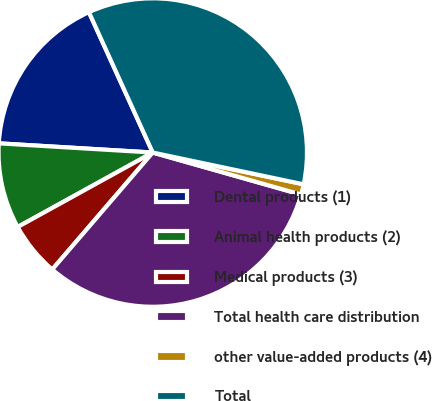Convert chart to OTSL. <chart><loc_0><loc_0><loc_500><loc_500><pie_chart><fcel>Dental products (1)<fcel>Animal health products (2)<fcel>Medical products (3)<fcel>Total health care distribution<fcel>other value-added products (4)<fcel>Total<nl><fcel>17.26%<fcel>8.97%<fcel>5.68%<fcel>31.91%<fcel>1.09%<fcel>35.1%<nl></chart> 